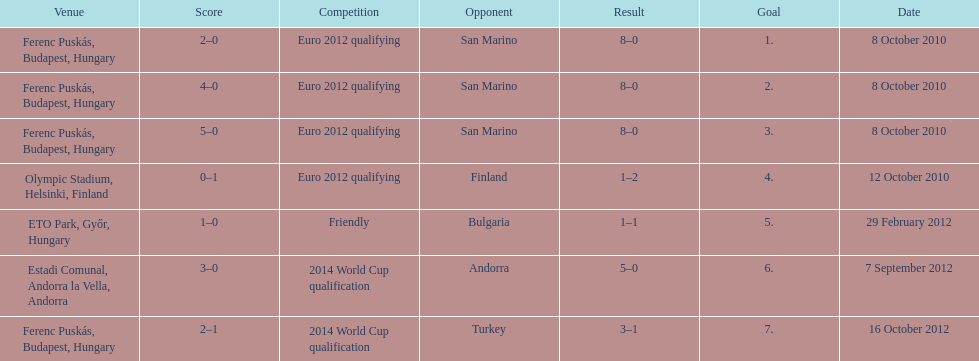How many consecutive games were goals were against san marino? 3. 